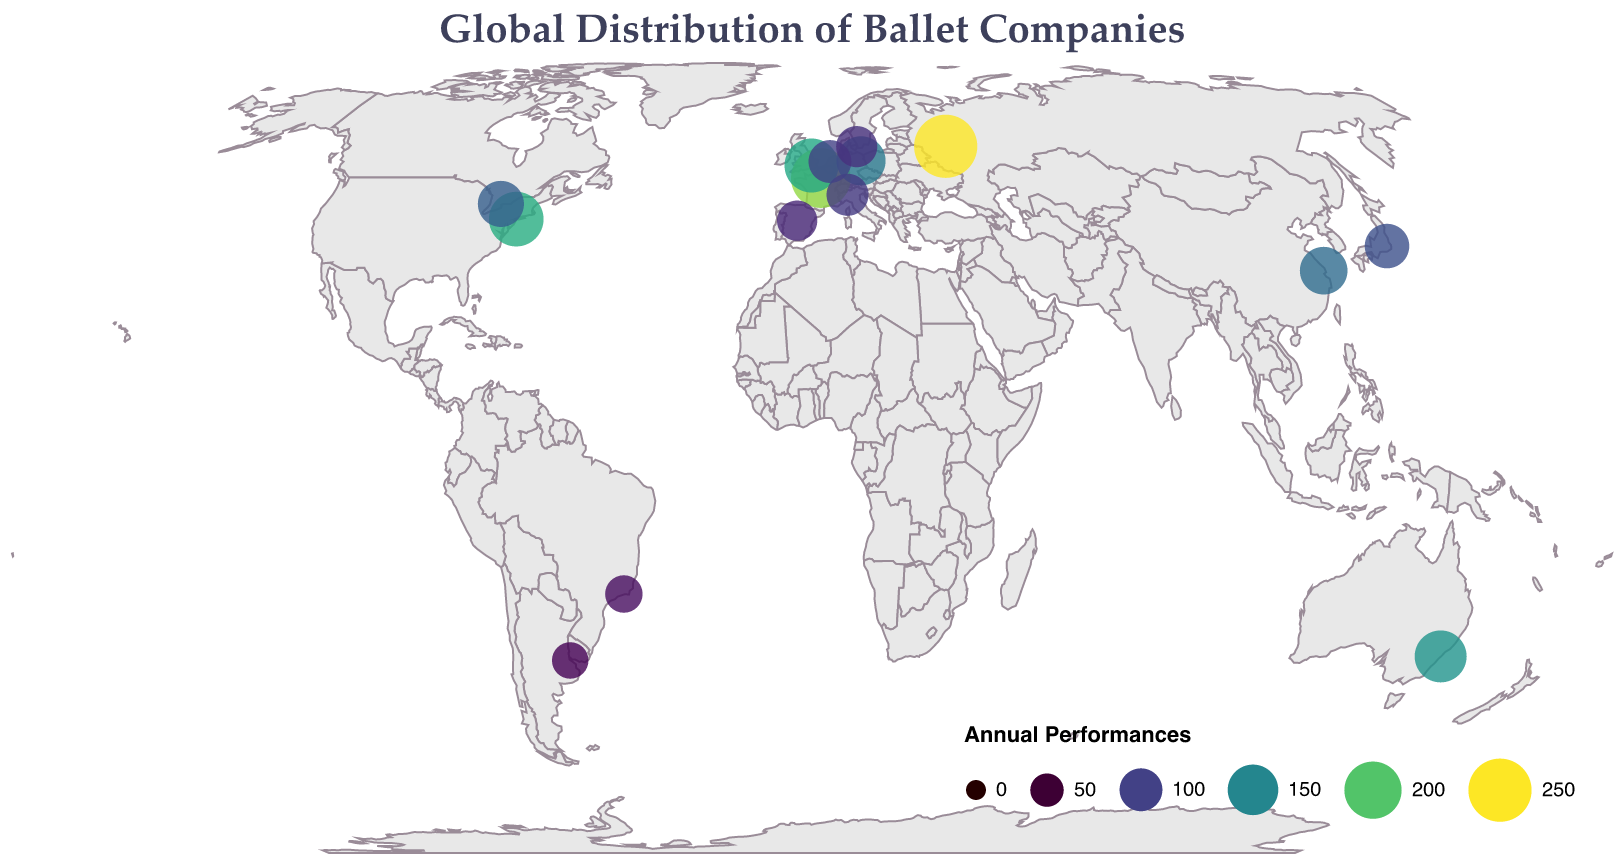Which company has the highest number of annual performances? The visual representation should indicate which circle is the largest by its size, and the tooltip provides the actual number of annual performances. Bolshoi Ballet in Moscow, Russia, is represented with the largest circle.
Answer: Bolshoi Ballet Which city has the least number of annual ballet performances? Observing the smaller circles and using the tooltip to find the city along with the corresponding annual performances will show that Buenos Aires, Argentina, with Teatro Colón Ballet has the smallest circle.
Answer: Buenos Aires How many companies perform more than 150 annual performances? Count the number of circles that are larger in size and a tooltip value greater than 150. There are four companies: Bolshoi Ballet, American Ballet Theatre, Paris Opera Ballet, and The Australian Ballet.
Answer: 4 Which continents host these ballet companies? By looking at the geographic distribution of the points on the map, it's possible to identify the continents. The companies are located in North America, Europe, Asia, South America, and Oceania.
Answer: North America, Europe, Asia, South America, Oceania Compare the performances of the ballet companies in New York and Tokyo. Which city has more annual performances? Look at the tooltip for the respective cities to see the annual performances. American Ballet Theatre in New York has 180, while Tokyo Ballet in Tokyo has 110.
Answer: New York What is the total number of annual performances by ballet companies in Europe? Identify all European cities (Paris, London, Berlin, Milan, Amsterdam, Copenhagen, Madrid), then sum their annual performances: 220 (Paris) + 175 (London) + 140 (Berlin) + 95 (Milan) + 100 (Amsterdam) + 90 (Copenhagen) + 85 (Madrid) = 905.
Answer: 905 Which company in Australia has how many annual performances? Locate Sydney on the map, use the tooltip to find out the name and annual performances of the ballet company there. The Australian Ballet in Sydney has 160 annual performances.
Answer: 160 Which country has multiple cities with ballet companies listed in the data? Review the tooltip information for each point on the map to see the country associated with each city. All listed ballet companies are from different cities in different countries, hence no repetition.
Answer: None Do any ballet companies in the Southern Hemisphere have more than 100 annual performances? Identify cities in the Southern Hemisphere (Sydney, Rio de Janeiro, Buenos Aires) and check the tooltip for their annual performances. The Australian Ballet in Sydney has 160, which is greater than 100.
Answer: Yes What is the average number of annual performances of the ballet companies listed? Sum the annual performances of all listed companies and divide by the number of companies: (250 + 180 + 220 + 175 + 130 + 160 + 140 + 120 + 110 + 95 + 85 + 100 + 90 + 70 + 65) = 1990, and there are 15 companies, so the average is 1990 / 15 = 132.67.
Answer: 132.67 